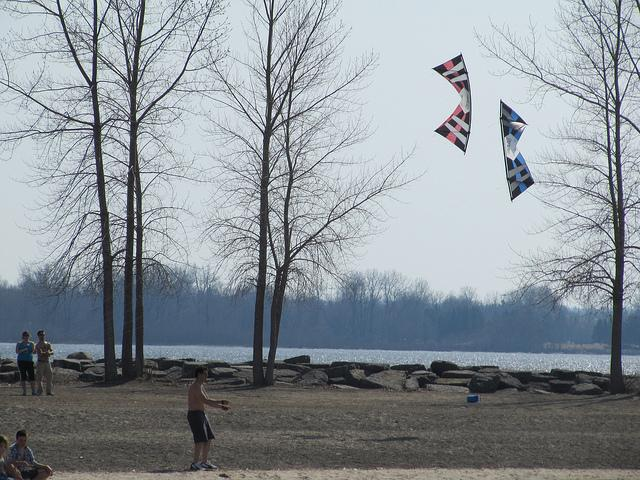What are the kites in most danger of getting stuck in? Please explain your reasoning. trees. The kites are flying close to the branches. 